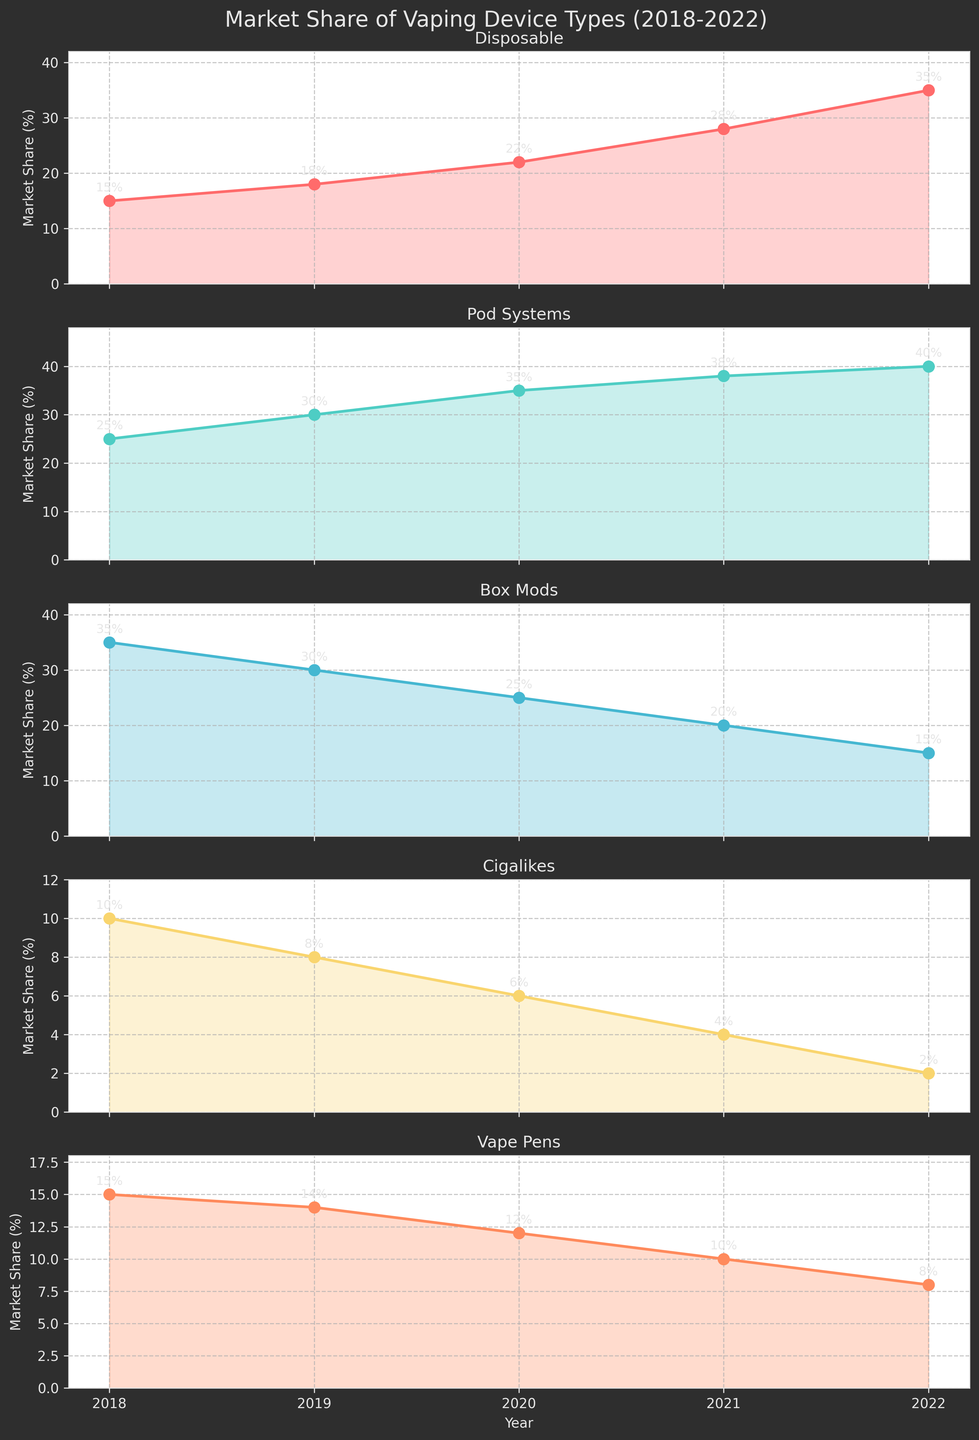What's the title of the figure? The title appears at the top of the plot and provides an overview of what the figure represents. Here, it states the topic and the timeframe under consideration.
Answer: Market Share of Vaping Device Types (2018-2022) What device type had the highest market share in 2022? To find the answer, look at the plots for each device type and identify the highest market share value for the year 2022. Compare these values to determine the largest.
Answer: Disposable How has the market share of Pod Systems changed from 2018 to 2022? Focus on the subplot for Pod Systems. Note the market share in 2018 and compare it to the value in 2022 by subtracting the former from the latter.
Answer: Increased from 25% to 40% Which device type saw the largest increase in market share over the 5 years? Examine all subplots and calculate the difference between the market share in 2022 and that in 2018 for each device type. The device with the largest difference is the answer.
Answer: Disposable Did any device types experience a decline in market share? If so, which ones? Look at each subplot and compare the starting and ending market shares (2018 vs 2022). Identify any device types where the market share decreased over this period.
Answer: Box Mods, Cigalikes, Vape Pens What is the average market share of Vape Pens across the five years? Sum the market share percentages of Vape Pens for all five years and divide by the number of years.
Answer: (15 + 14 + 12 + 10 + 8) / 5 = 11.8% In what year did Box Mods have the largest market share? Review the Box Mods subplot and identify the year corresponding to the highest market share value.
Answer: 2018 Compare the market share trends of Disposable and Cigalikes over the five years. Analyze the subplots for both device types. Disposable shows a steady increase while Cigalikes show a steady decline. Summarize these observations.
Answer: Disposable increased, Cigalikes decreased What is the combined market share percentage of Pod Systems and Box Mods in 2020? Locate the market shares of Pod Systems and Box Mods in the 2020 plot. Add these percentages together.
Answer: 35% (Pod Systems) + 25% (Box Mods) = 60% Which device type had the most stable market share over the five years? Define stability as minimal fluctuation. Assess the degree of variation in market share for each device type by evaluating the difference between their highest and lowest values over the years. The device with the smallest range is the most stable.
Answer: Vape Pens 